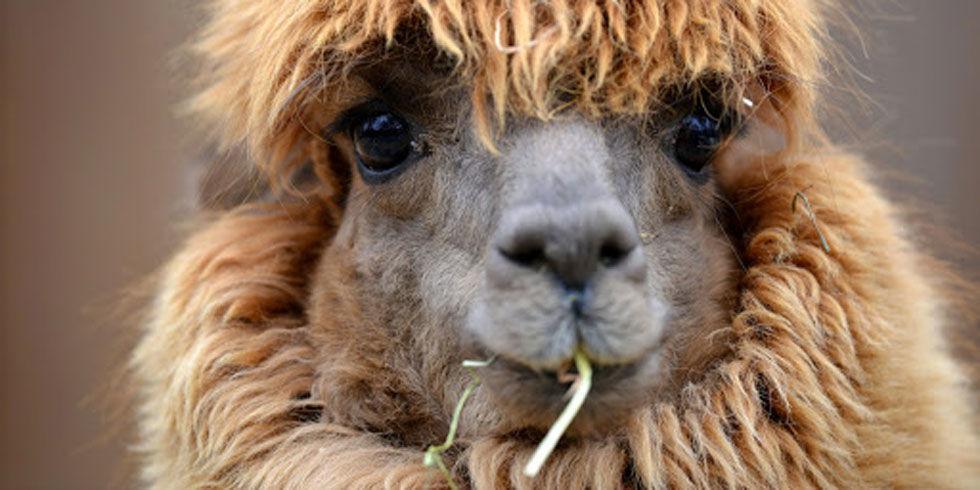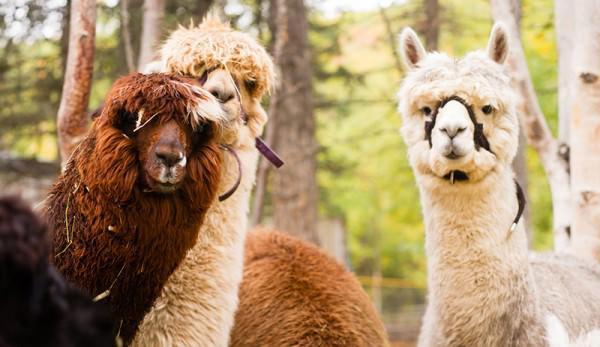The first image is the image on the left, the second image is the image on the right. Considering the images on both sides, is "The left and right image contains a total of four llamas." valid? Answer yes or no. Yes. The first image is the image on the left, the second image is the image on the right. Analyze the images presented: Is the assertion "An image shows two llamas, with the mouth of the one on the left touching the face of the one on the right." valid? Answer yes or no. No. 